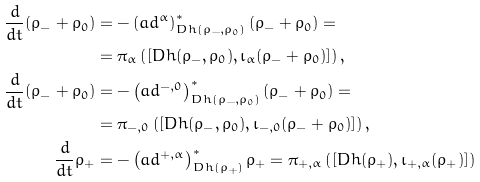<formula> <loc_0><loc_0><loc_500><loc_500>\frac { d } { d t } ( \rho _ { - } + \rho _ { 0 } ) & = - \left ( a d ^ { \alpha } \right ) ^ { * } _ { D h ( \rho _ { - } , \rho _ { 0 } ) } ( \rho _ { - } + \rho _ { 0 } ) = \\ & = \pi _ { \alpha } \left ( [ D h ( \rho _ { - } , \rho _ { 0 } ) , \iota _ { \alpha } ( \rho _ { - } + \rho _ { 0 } ) ] \right ) , \\ \frac { d } { d t } ( \rho _ { - } + \rho _ { 0 } ) & = - \left ( a d ^ { - , 0 } \right ) ^ { * } _ { D h ( \rho _ { - } , \rho _ { 0 } ) } ( \rho _ { - } + \rho _ { 0 } ) = \\ & = \pi _ { - , 0 } \left ( [ D h ( \rho _ { - } , \rho _ { 0 } ) , \iota _ { - , 0 } ( \rho _ { - } + \rho _ { 0 } ) ] \right ) , \\ \frac { d } { d t } \rho _ { + } & = - \left ( a d ^ { + , \alpha } \right ) ^ { * } _ { D h ( \rho _ { + } ) } \rho _ { + } = \pi _ { + , \alpha } \left ( [ D h ( \rho _ { + } ) , \iota _ { + , \alpha } ( \rho _ { + } ) ] \right )</formula> 